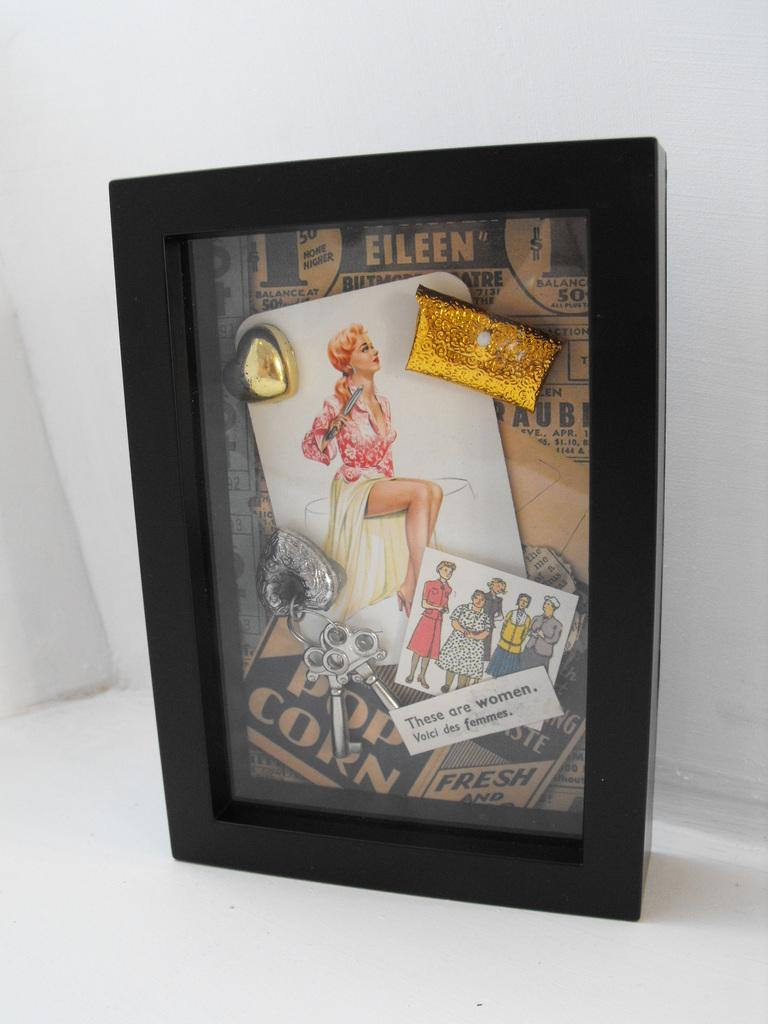<image>
Share a concise interpretation of the image provided. the name eileen is on the photo with a black frame 